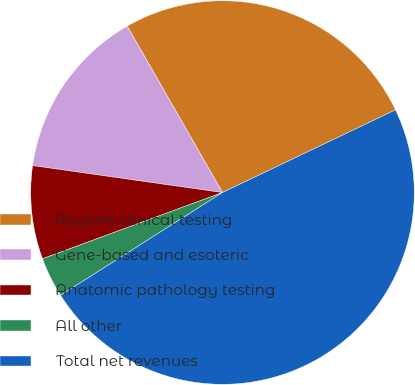Convert chart to OTSL. <chart><loc_0><loc_0><loc_500><loc_500><pie_chart><fcel>Routine clinical testing<fcel>Gene-based and esoteric<fcel>Anatomic pathology testing<fcel>All other<fcel>Total net revenues<nl><fcel>26.18%<fcel>14.48%<fcel>7.86%<fcel>3.39%<fcel>48.1%<nl></chart> 